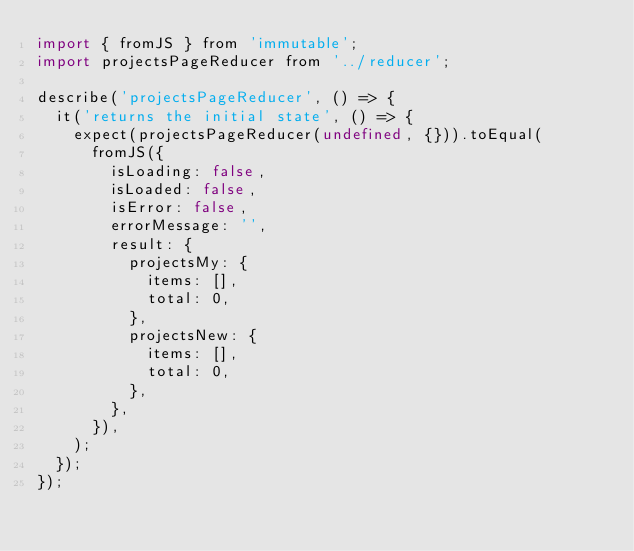Convert code to text. <code><loc_0><loc_0><loc_500><loc_500><_JavaScript_>import { fromJS } from 'immutable';
import projectsPageReducer from '../reducer';

describe('projectsPageReducer', () => {
  it('returns the initial state', () => {
    expect(projectsPageReducer(undefined, {})).toEqual(
      fromJS({
        isLoading: false,
        isLoaded: false,
        isError: false,
        errorMessage: '',
        result: {
          projectsMy: {
            items: [],
            total: 0,
          },
          projectsNew: {
            items: [],
            total: 0,
          },
        },
      }),
    );
  });
});
</code> 